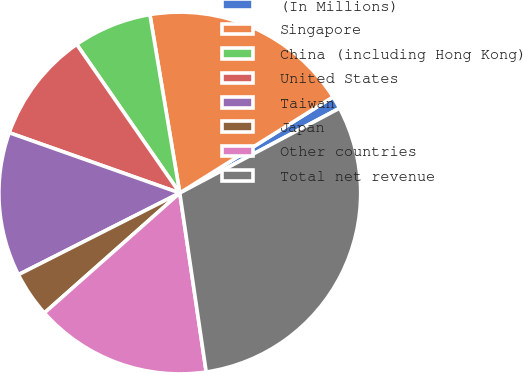Convert chart to OTSL. <chart><loc_0><loc_0><loc_500><loc_500><pie_chart><fcel>(In Millions)<fcel>Singapore<fcel>China (including Hong Kong)<fcel>United States<fcel>Taiwan<fcel>Japan<fcel>Other countries<fcel>Total net revenue<nl><fcel>1.15%<fcel>18.73%<fcel>7.01%<fcel>9.94%<fcel>12.87%<fcel>4.08%<fcel>15.8%<fcel>30.44%<nl></chart> 